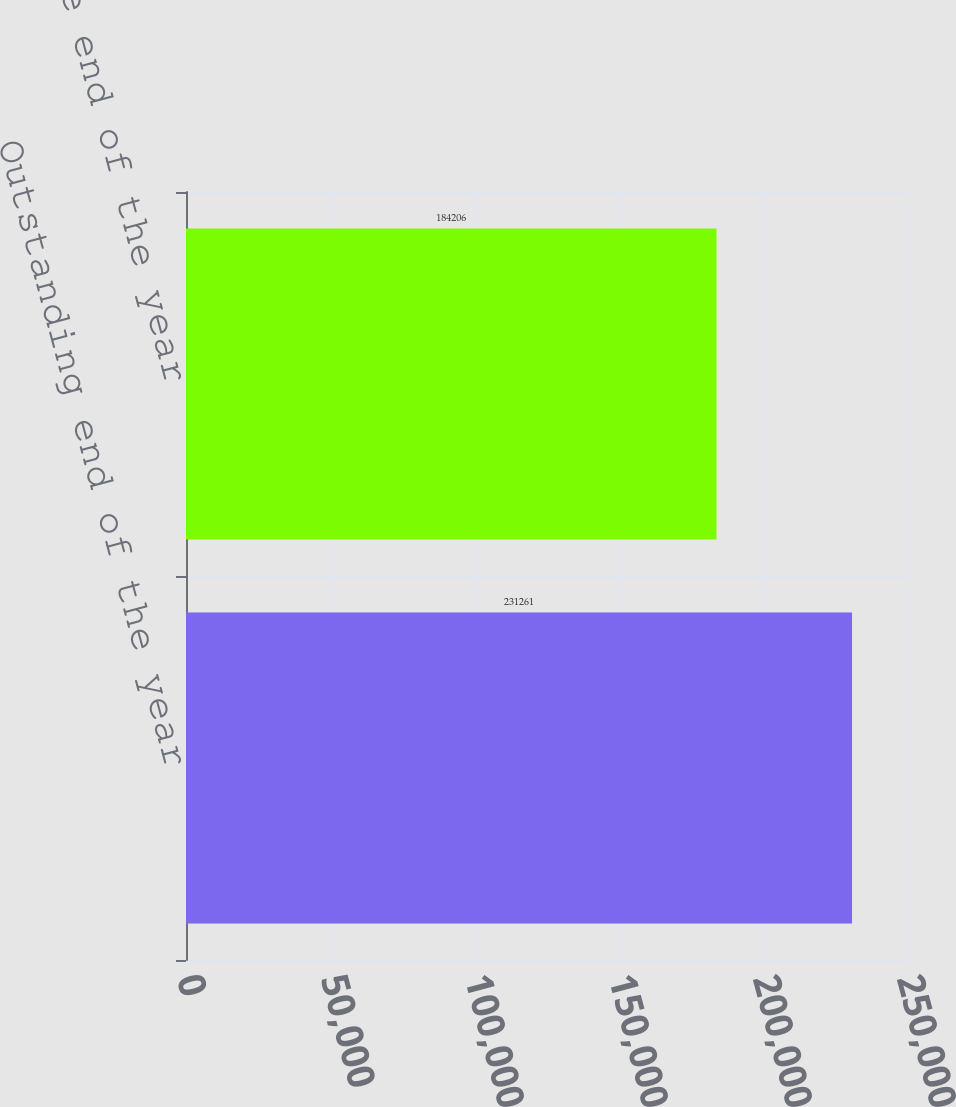Convert chart to OTSL. <chart><loc_0><loc_0><loc_500><loc_500><bar_chart><fcel>Outstanding end of the year<fcel>Exercisable end of the year<nl><fcel>231261<fcel>184206<nl></chart> 